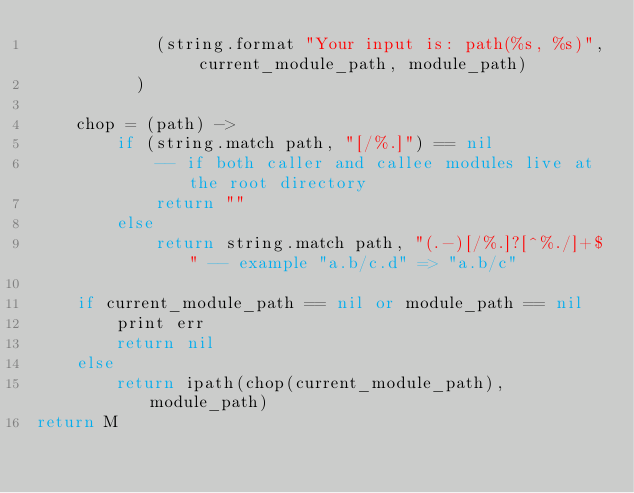Convert code to text. <code><loc_0><loc_0><loc_500><loc_500><_MoonScript_>            (string.format "Your input is: path(%s, %s)", current_module_path, module_path)
          )
    
    chop = (path) -> 
        if (string.match path, "[/%.]") == nil 
            -- if both caller and callee modules live at the root directory
            return ""
        else 
            return string.match path, "(.-)[/%.]?[^%./]+$" -- example "a.b/c.d" => "a.b/c"

    if current_module_path == nil or module_path == nil 
        print err
        return nil
    else 
        return ipath(chop(current_module_path), module_path)
return M</code> 